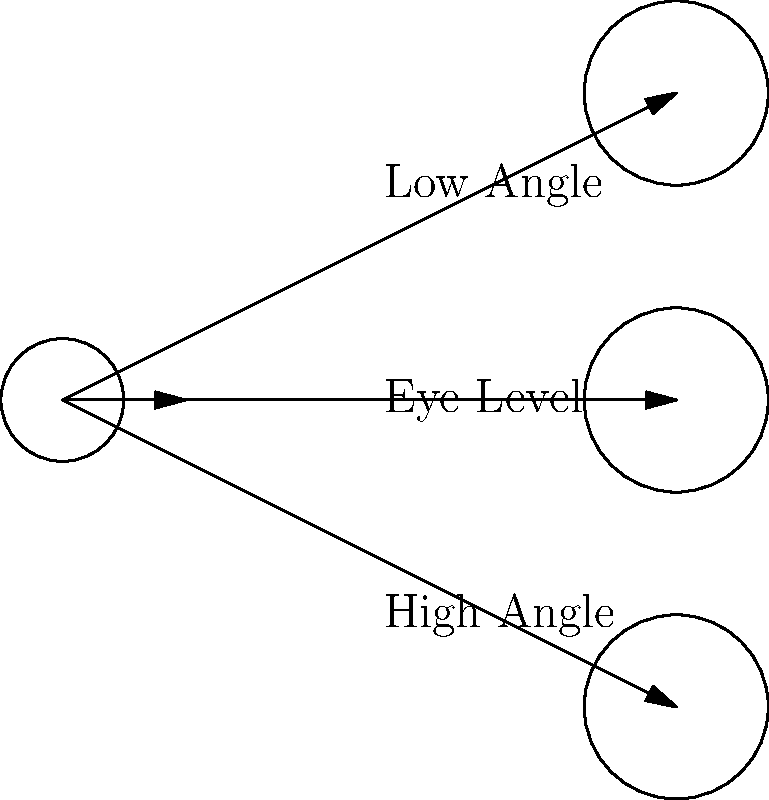In the diagram above, three different camera angles are shown: low angle, high angle, and eye level. Which of these camera angles would be most effective for making a character appear powerful and dominant in a scene? To answer this question, let's consider the effects of each camera angle on the viewer's perception:

1. Eye Level Shot:
   - This is a neutral angle, placing the viewer at the same level as the subject.
   - It creates a sense of equality between the viewer and the character.
   - This angle is often used for normal dialogue scenes or to establish a character.

2. High Angle Shot:
   - The camera looks down on the subject from above.
   - This angle tends to make the subject appear smaller, weaker, or vulnerable.
   - It can create a sense of the character being overwhelmed or insignificant.

3. Low Angle Shot:
   - The camera looks up at the subject from below.
   - This angle makes the subject appear larger, taller, and more imposing.
   - It creates a sense of power, dominance, and importance for the character.

Given that we want to make a character appear powerful and dominant, the low angle shot would be the most effective. By positioning the camera below the subject and looking up, we create the illusion of the character towering over the viewer, which enhances their perceived strength and authority.

This technique is often used in films to establish powerful characters or to show a shift in power dynamics between characters. It's a visual storytelling tool that can convey information about a character's status or importance without relying on dialogue or explicit exposition.
Answer: Low angle shot 